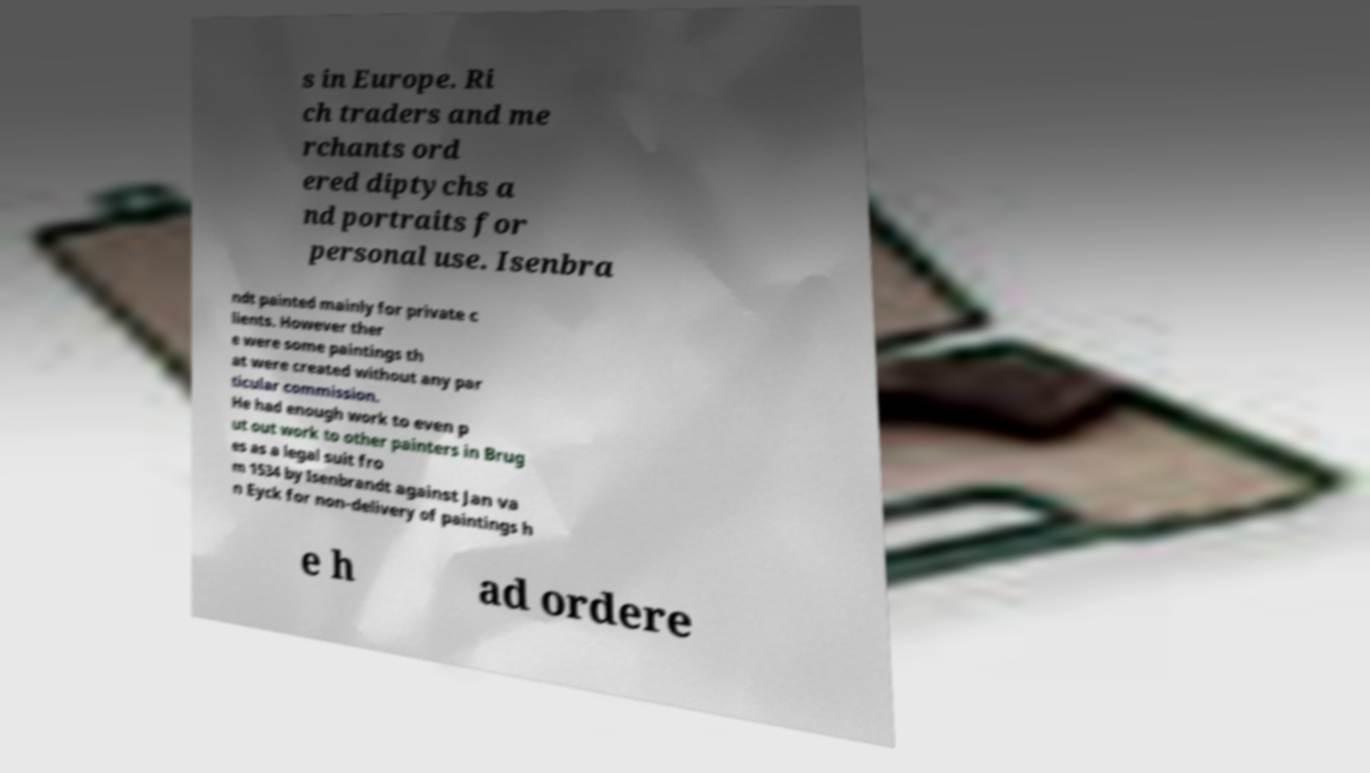Could you assist in decoding the text presented in this image and type it out clearly? s in Europe. Ri ch traders and me rchants ord ered diptychs a nd portraits for personal use. Isenbra ndt painted mainly for private c lients. However ther e were some paintings th at were created without any par ticular commission. He had enough work to even p ut out work to other painters in Brug es as a legal suit fro m 1534 by Isenbrandt against Jan va n Eyck for non-delivery of paintings h e h ad ordere 